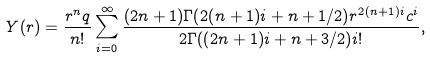<formula> <loc_0><loc_0><loc_500><loc_500>Y ( r ) = \frac { r ^ { n } q } { n ! } \sum _ { i = 0 } ^ { \infty } { \frac { ( 2 n + 1 ) \Gamma ( 2 ( n + 1 ) i + n + 1 / 2 ) r ^ { 2 ( n + 1 ) i } c ^ { i } } { 2 \Gamma ( ( 2 n + 1 ) i + n + 3 / 2 ) i ! } } ,</formula> 